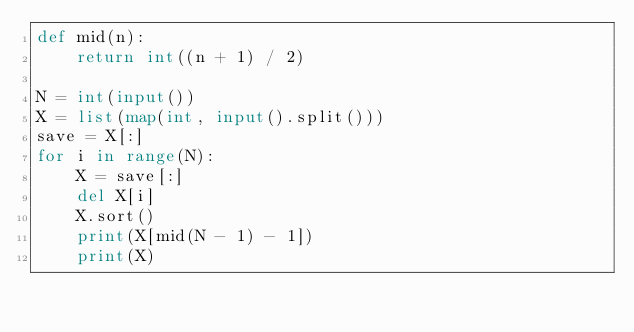Convert code to text. <code><loc_0><loc_0><loc_500><loc_500><_Python_>def mid(n):
    return int((n + 1) / 2)

N = int(input())
X = list(map(int, input().split()))
save = X[:]
for i in range(N):
    X = save[:]
    del X[i]
    X.sort()
    print(X[mid(N - 1) - 1])
    print(X)
</code> 